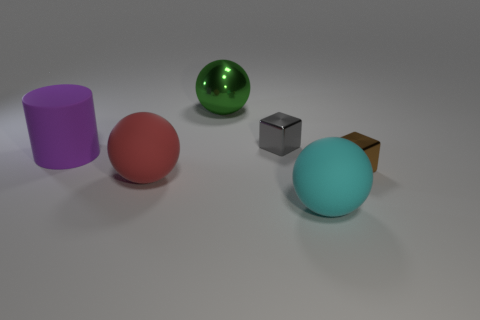There is a large purple cylinder; are there any purple things on the right side of it?
Provide a short and direct response. No. There is a shiny thing that is in front of the big purple object; is its shape the same as the small metallic object that is behind the big purple thing?
Provide a succinct answer. Yes. There is a tiny gray thing that is the same shape as the brown metallic object; what is its material?
Provide a short and direct response. Metal. How many cubes are big green metal objects or purple rubber things?
Provide a short and direct response. 0. How many purple cylinders have the same material as the brown thing?
Ensure brevity in your answer.  0. Is the large thing that is on the left side of the large red rubber ball made of the same material as the big ball left of the green ball?
Offer a terse response. Yes. What number of large matte cylinders are behind the thing that is behind the small block behind the cylinder?
Give a very brief answer. 0. There is a shiny block in front of the purple thing; does it have the same color as the big rubber ball that is behind the cyan sphere?
Provide a short and direct response. No. Is there anything else that is the same color as the cylinder?
Keep it short and to the point. No. What is the color of the big thing that is right of the big sphere that is behind the big cylinder?
Make the answer very short. Cyan. 